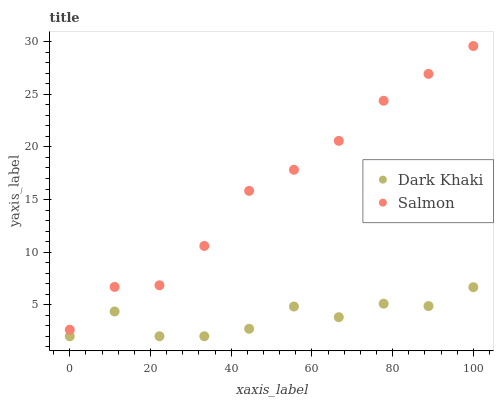Does Dark Khaki have the minimum area under the curve?
Answer yes or no. Yes. Does Salmon have the maximum area under the curve?
Answer yes or no. Yes. Does Salmon have the minimum area under the curve?
Answer yes or no. No. Is Salmon the smoothest?
Answer yes or no. Yes. Is Dark Khaki the roughest?
Answer yes or no. Yes. Is Salmon the roughest?
Answer yes or no. No. Does Dark Khaki have the lowest value?
Answer yes or no. Yes. Does Salmon have the lowest value?
Answer yes or no. No. Does Salmon have the highest value?
Answer yes or no. Yes. Is Dark Khaki less than Salmon?
Answer yes or no. Yes. Is Salmon greater than Dark Khaki?
Answer yes or no. Yes. Does Dark Khaki intersect Salmon?
Answer yes or no. No. 